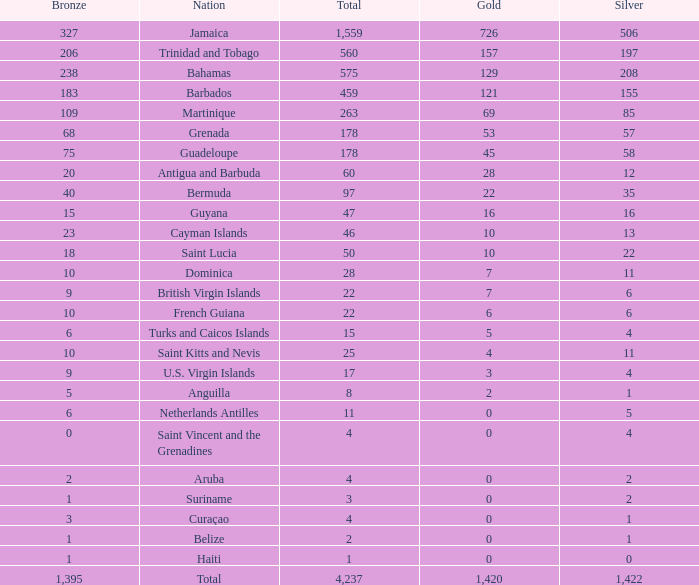Could you parse the entire table? {'header': ['Bronze', 'Nation', 'Total', 'Gold', 'Silver'], 'rows': [['327', 'Jamaica', '1,559', '726', '506'], ['206', 'Trinidad and Tobago', '560', '157', '197'], ['238', 'Bahamas', '575', '129', '208'], ['183', 'Barbados', '459', '121', '155'], ['109', 'Martinique', '263', '69', '85'], ['68', 'Grenada', '178', '53', '57'], ['75', 'Guadeloupe', '178', '45', '58'], ['20', 'Antigua and Barbuda', '60', '28', '12'], ['40', 'Bermuda', '97', '22', '35'], ['15', 'Guyana', '47', '16', '16'], ['23', 'Cayman Islands', '46', '10', '13'], ['18', 'Saint Lucia', '50', '10', '22'], ['10', 'Dominica', '28', '7', '11'], ['9', 'British Virgin Islands', '22', '7', '6'], ['10', 'French Guiana', '22', '6', '6'], ['6', 'Turks and Caicos Islands', '15', '5', '4'], ['10', 'Saint Kitts and Nevis', '25', '4', '11'], ['9', 'U.S. Virgin Islands', '17', '3', '4'], ['5', 'Anguilla', '8', '2', '1'], ['6', 'Netherlands Antilles', '11', '0', '5'], ['0', 'Saint Vincent and the Grenadines', '4', '0', '4'], ['2', 'Aruba', '4', '0', '2'], ['1', 'Suriname', '3', '0', '2'], ['3', 'Curaçao', '4', '0', '1'], ['1', 'Belize', '2', '0', '1'], ['1', 'Haiti', '1', '0', '0'], ['1,395', 'Total', '4,237', '1,420', '1,422']]} What's the sum of Gold with a Bronze that's larger than 15, Silver that's smaller than 197, the Nation of Saint Lucia, and has a Total that is larger than 50? None. 